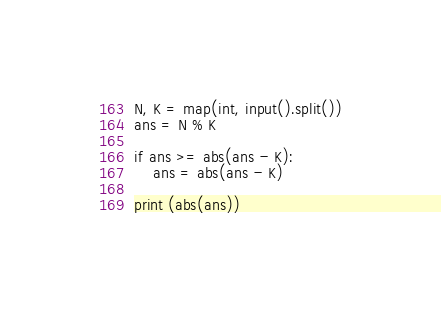<code> <loc_0><loc_0><loc_500><loc_500><_Python_>N, K = map(int, input().split())
ans = N % K

if ans >= abs(ans - K):
    ans = abs(ans - K)

print (abs(ans))</code> 